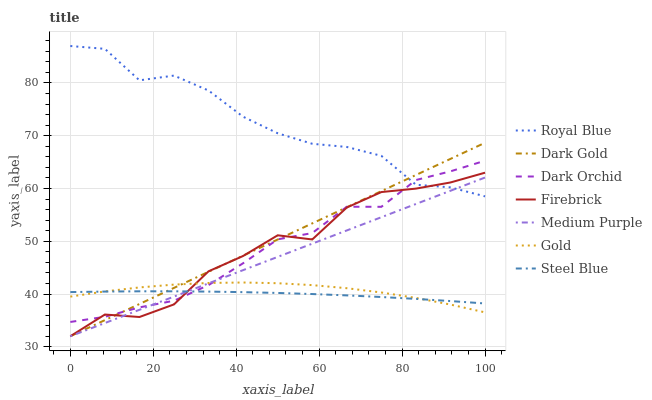Does Steel Blue have the minimum area under the curve?
Answer yes or no. Yes. Does Royal Blue have the maximum area under the curve?
Answer yes or no. Yes. Does Dark Gold have the minimum area under the curve?
Answer yes or no. No. Does Dark Gold have the maximum area under the curve?
Answer yes or no. No. Is Dark Gold the smoothest?
Answer yes or no. Yes. Is Firebrick the roughest?
Answer yes or no. Yes. Is Firebrick the smoothest?
Answer yes or no. No. Is Dark Gold the roughest?
Answer yes or no. No. Does Dark Gold have the lowest value?
Answer yes or no. Yes. Does Steel Blue have the lowest value?
Answer yes or no. No. Does Royal Blue have the highest value?
Answer yes or no. Yes. Does Dark Gold have the highest value?
Answer yes or no. No. Is Steel Blue less than Royal Blue?
Answer yes or no. Yes. Is Royal Blue greater than Steel Blue?
Answer yes or no. Yes. Does Royal Blue intersect Medium Purple?
Answer yes or no. Yes. Is Royal Blue less than Medium Purple?
Answer yes or no. No. Is Royal Blue greater than Medium Purple?
Answer yes or no. No. Does Steel Blue intersect Royal Blue?
Answer yes or no. No. 